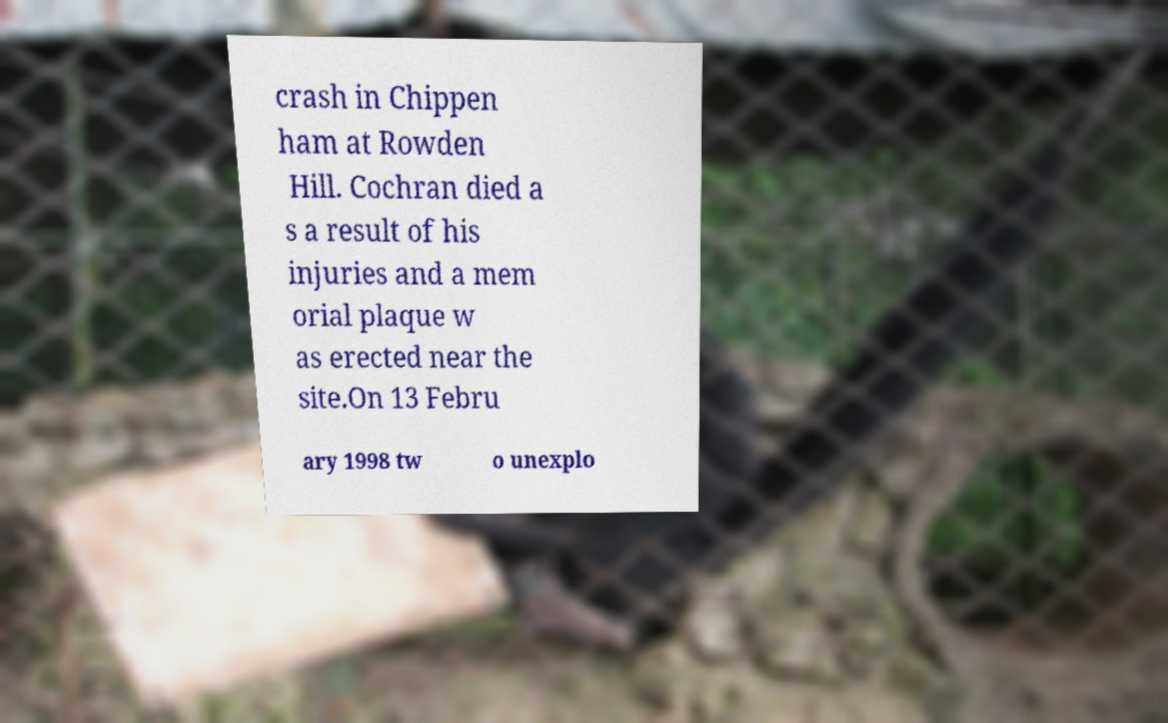I need the written content from this picture converted into text. Can you do that? crash in Chippen ham at Rowden Hill. Cochran died a s a result of his injuries and a mem orial plaque w as erected near the site.On 13 Febru ary 1998 tw o unexplo 